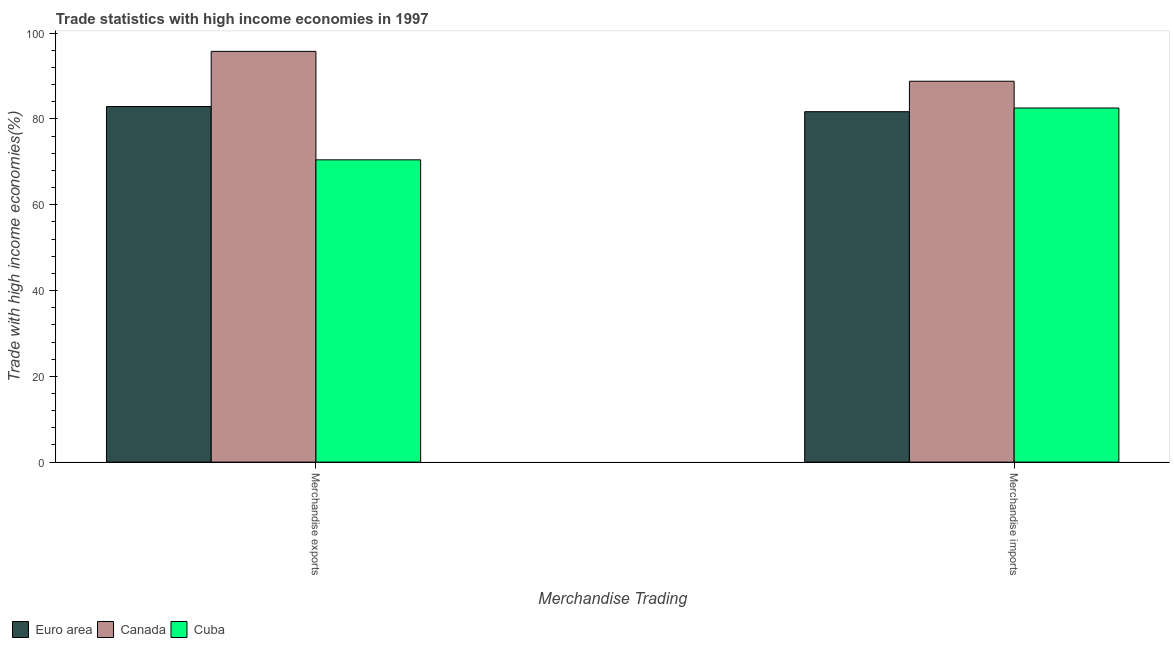How many groups of bars are there?
Give a very brief answer. 2. Are the number of bars on each tick of the X-axis equal?
Your answer should be compact. Yes. How many bars are there on the 1st tick from the left?
Your answer should be very brief. 3. What is the merchandise exports in Canada?
Provide a succinct answer. 95.76. Across all countries, what is the maximum merchandise imports?
Keep it short and to the point. 88.8. Across all countries, what is the minimum merchandise imports?
Offer a terse response. 81.7. In which country was the merchandise exports maximum?
Keep it short and to the point. Canada. What is the total merchandise exports in the graph?
Your answer should be compact. 249.14. What is the difference between the merchandise exports in Euro area and that in Cuba?
Offer a terse response. 12.43. What is the difference between the merchandise imports in Cuba and the merchandise exports in Euro area?
Keep it short and to the point. -0.34. What is the average merchandise imports per country?
Provide a short and direct response. 84.35. What is the difference between the merchandise exports and merchandise imports in Cuba?
Keep it short and to the point. -12.08. What is the ratio of the merchandise imports in Canada to that in Euro area?
Offer a very short reply. 1.09. In how many countries, is the merchandise exports greater than the average merchandise exports taken over all countries?
Your answer should be compact. 1. What does the 3rd bar from the left in Merchandise imports represents?
Your answer should be compact. Cuba. How many bars are there?
Ensure brevity in your answer.  6. What is the difference between two consecutive major ticks on the Y-axis?
Make the answer very short. 20. Does the graph contain any zero values?
Provide a succinct answer. No. Does the graph contain grids?
Give a very brief answer. No. Where does the legend appear in the graph?
Your answer should be very brief. Bottom left. How many legend labels are there?
Provide a succinct answer. 3. What is the title of the graph?
Provide a short and direct response. Trade statistics with high income economies in 1997. Does "Mali" appear as one of the legend labels in the graph?
Your response must be concise. No. What is the label or title of the X-axis?
Provide a short and direct response. Merchandise Trading. What is the label or title of the Y-axis?
Keep it short and to the point. Trade with high income economies(%). What is the Trade with high income economies(%) of Euro area in Merchandise exports?
Your answer should be compact. 82.9. What is the Trade with high income economies(%) in Canada in Merchandise exports?
Give a very brief answer. 95.76. What is the Trade with high income economies(%) of Cuba in Merchandise exports?
Make the answer very short. 70.47. What is the Trade with high income economies(%) of Euro area in Merchandise imports?
Keep it short and to the point. 81.7. What is the Trade with high income economies(%) of Canada in Merchandise imports?
Your response must be concise. 88.8. What is the Trade with high income economies(%) of Cuba in Merchandise imports?
Your answer should be compact. 82.56. Across all Merchandise Trading, what is the maximum Trade with high income economies(%) in Euro area?
Ensure brevity in your answer.  82.9. Across all Merchandise Trading, what is the maximum Trade with high income economies(%) of Canada?
Your answer should be compact. 95.76. Across all Merchandise Trading, what is the maximum Trade with high income economies(%) in Cuba?
Your response must be concise. 82.56. Across all Merchandise Trading, what is the minimum Trade with high income economies(%) in Euro area?
Provide a short and direct response. 81.7. Across all Merchandise Trading, what is the minimum Trade with high income economies(%) in Canada?
Your response must be concise. 88.8. Across all Merchandise Trading, what is the minimum Trade with high income economies(%) of Cuba?
Give a very brief answer. 70.47. What is the total Trade with high income economies(%) of Euro area in the graph?
Offer a very short reply. 164.6. What is the total Trade with high income economies(%) of Canada in the graph?
Make the answer very short. 184.56. What is the total Trade with high income economies(%) in Cuba in the graph?
Provide a succinct answer. 153.03. What is the difference between the Trade with high income economies(%) in Euro area in Merchandise exports and that in Merchandise imports?
Provide a short and direct response. 1.21. What is the difference between the Trade with high income economies(%) of Canada in Merchandise exports and that in Merchandise imports?
Give a very brief answer. 6.96. What is the difference between the Trade with high income economies(%) in Cuba in Merchandise exports and that in Merchandise imports?
Make the answer very short. -12.08. What is the difference between the Trade with high income economies(%) in Euro area in Merchandise exports and the Trade with high income economies(%) in Canada in Merchandise imports?
Provide a succinct answer. -5.9. What is the difference between the Trade with high income economies(%) in Euro area in Merchandise exports and the Trade with high income economies(%) in Cuba in Merchandise imports?
Make the answer very short. 0.34. What is the difference between the Trade with high income economies(%) of Canada in Merchandise exports and the Trade with high income economies(%) of Cuba in Merchandise imports?
Provide a succinct answer. 13.2. What is the average Trade with high income economies(%) of Euro area per Merchandise Trading?
Make the answer very short. 82.3. What is the average Trade with high income economies(%) of Canada per Merchandise Trading?
Make the answer very short. 92.28. What is the average Trade with high income economies(%) in Cuba per Merchandise Trading?
Make the answer very short. 76.52. What is the difference between the Trade with high income economies(%) in Euro area and Trade with high income economies(%) in Canada in Merchandise exports?
Your answer should be compact. -12.86. What is the difference between the Trade with high income economies(%) in Euro area and Trade with high income economies(%) in Cuba in Merchandise exports?
Make the answer very short. 12.43. What is the difference between the Trade with high income economies(%) of Canada and Trade with high income economies(%) of Cuba in Merchandise exports?
Offer a very short reply. 25.29. What is the difference between the Trade with high income economies(%) of Euro area and Trade with high income economies(%) of Canada in Merchandise imports?
Keep it short and to the point. -7.1. What is the difference between the Trade with high income economies(%) in Euro area and Trade with high income economies(%) in Cuba in Merchandise imports?
Offer a terse response. -0.86. What is the difference between the Trade with high income economies(%) in Canada and Trade with high income economies(%) in Cuba in Merchandise imports?
Offer a very short reply. 6.24. What is the ratio of the Trade with high income economies(%) of Euro area in Merchandise exports to that in Merchandise imports?
Offer a terse response. 1.01. What is the ratio of the Trade with high income economies(%) of Canada in Merchandise exports to that in Merchandise imports?
Ensure brevity in your answer.  1.08. What is the ratio of the Trade with high income economies(%) of Cuba in Merchandise exports to that in Merchandise imports?
Your response must be concise. 0.85. What is the difference between the highest and the second highest Trade with high income economies(%) in Euro area?
Provide a succinct answer. 1.21. What is the difference between the highest and the second highest Trade with high income economies(%) of Canada?
Your answer should be compact. 6.96. What is the difference between the highest and the second highest Trade with high income economies(%) of Cuba?
Offer a very short reply. 12.08. What is the difference between the highest and the lowest Trade with high income economies(%) of Euro area?
Your answer should be very brief. 1.21. What is the difference between the highest and the lowest Trade with high income economies(%) in Canada?
Provide a succinct answer. 6.96. What is the difference between the highest and the lowest Trade with high income economies(%) of Cuba?
Make the answer very short. 12.08. 